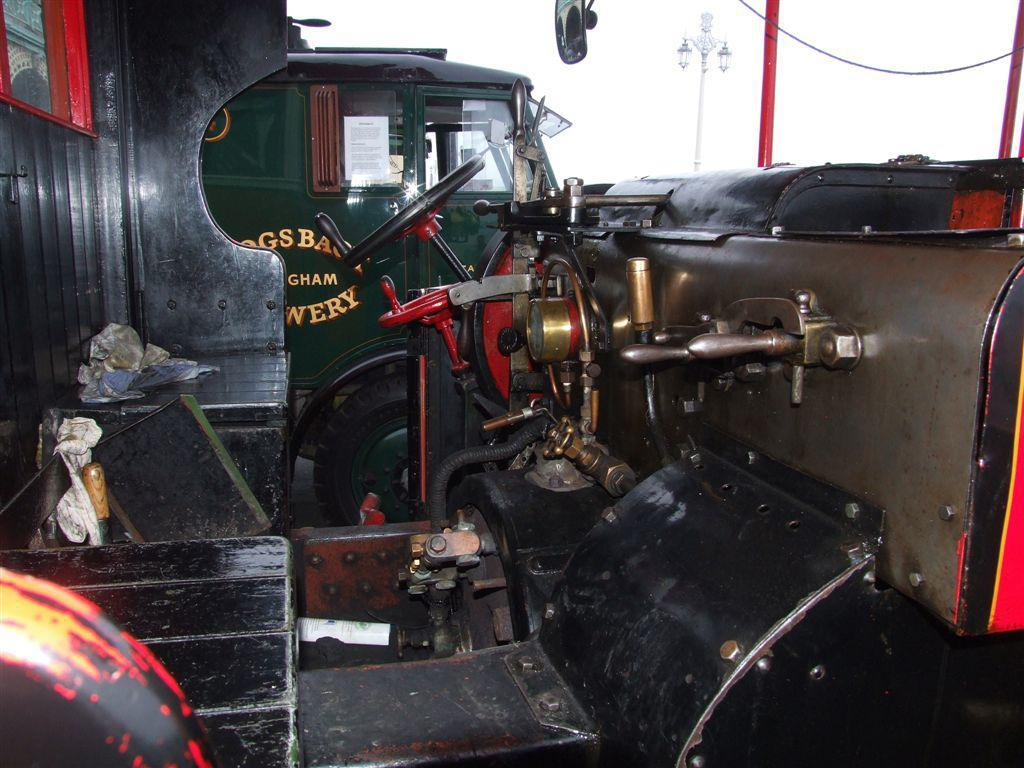What is located in the center of the image? There are vehicles in the center of the image. What can be seen on the right side of the image? There are poles on the right side of the image. How would you describe the sky in the image? The sky is cloudy in the image. How many chairs are placed on the farm in the image? There is no farm or chairs present in the image. What emotion does the image evoke in the viewer? The image does not evoke any specific emotion, such as disgust, as it only contains vehicles and poles. 